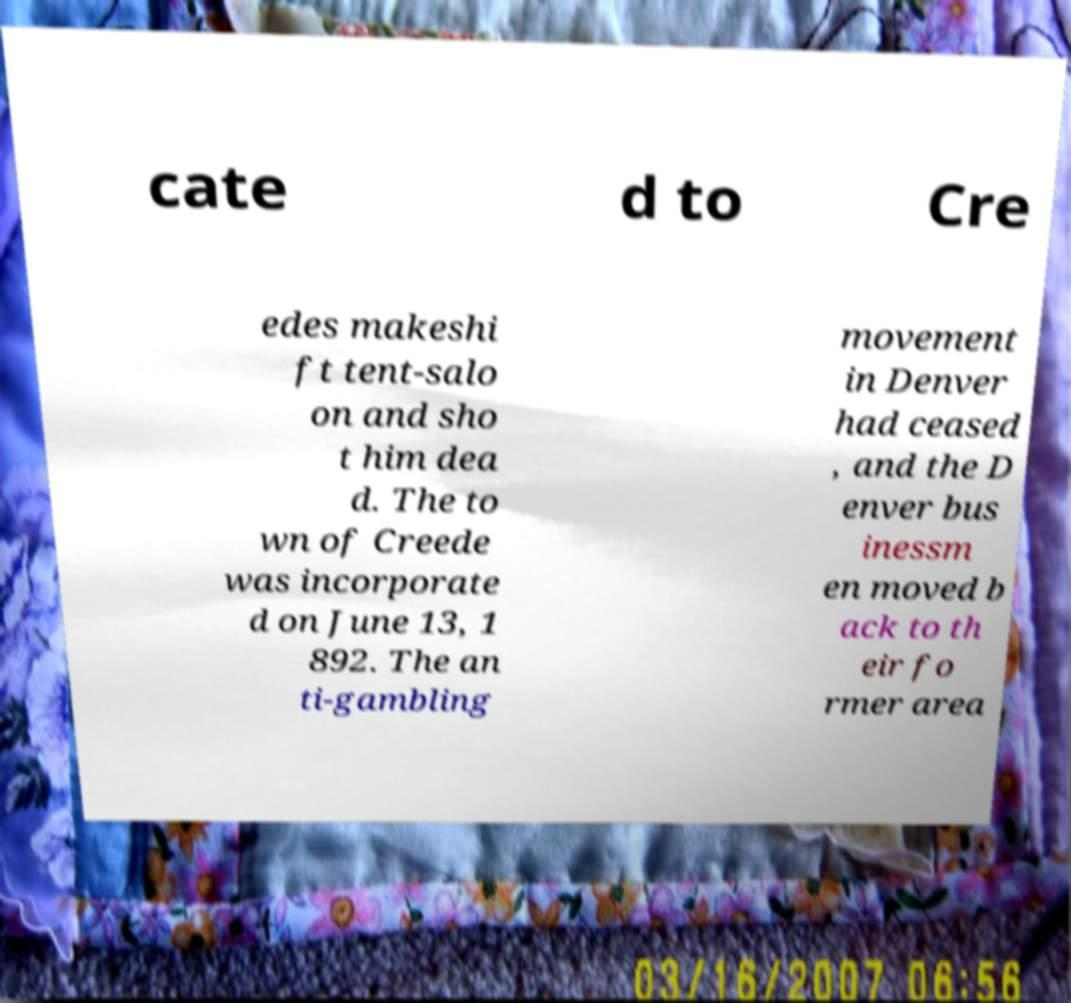Could you assist in decoding the text presented in this image and type it out clearly? cate d to Cre edes makeshi ft tent-salo on and sho t him dea d. The to wn of Creede was incorporate d on June 13, 1 892. The an ti-gambling movement in Denver had ceased , and the D enver bus inessm en moved b ack to th eir fo rmer area 